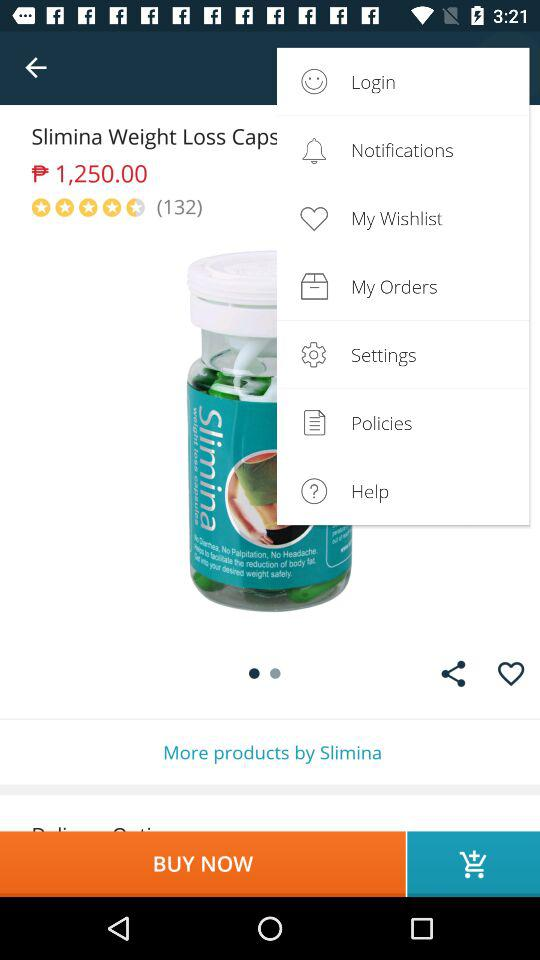How many people have rated Slimina weight loss capsules? There are 132 people who have rated the Slimina weight loss capsules. 